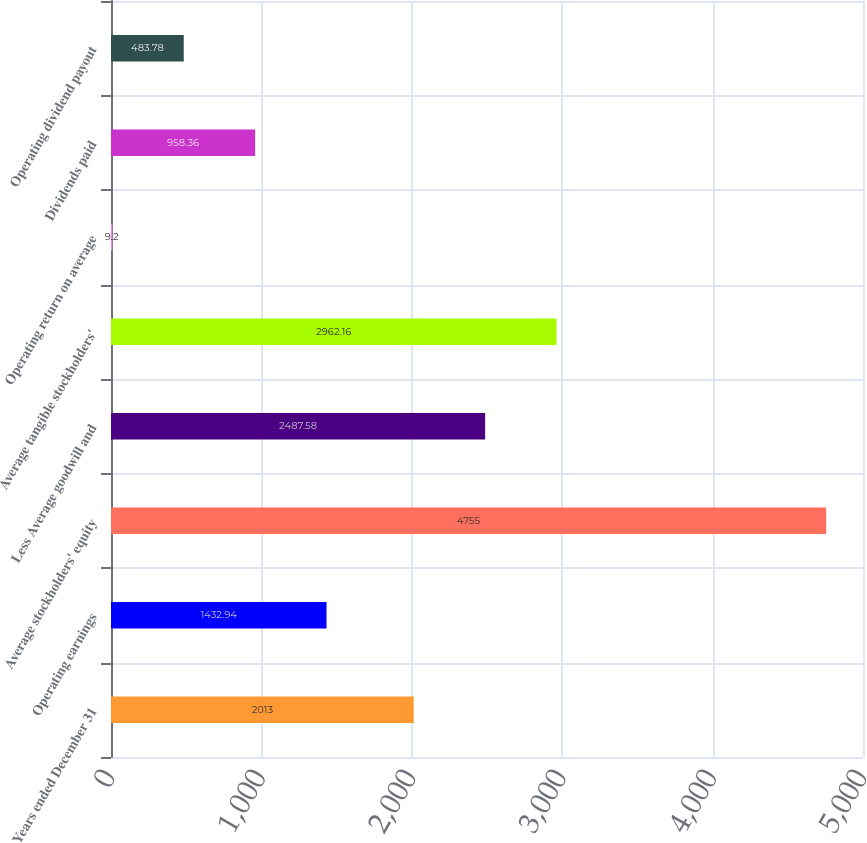<chart> <loc_0><loc_0><loc_500><loc_500><bar_chart><fcel>Years ended December 31<fcel>Operating earnings<fcel>Average stockholders' equity<fcel>Less Average goodwill and<fcel>Average tangible stockholders'<fcel>Operating return on average<fcel>Dividends paid<fcel>Operating dividend payout<nl><fcel>2013<fcel>1432.94<fcel>4755<fcel>2487.58<fcel>2962.16<fcel>9.2<fcel>958.36<fcel>483.78<nl></chart> 